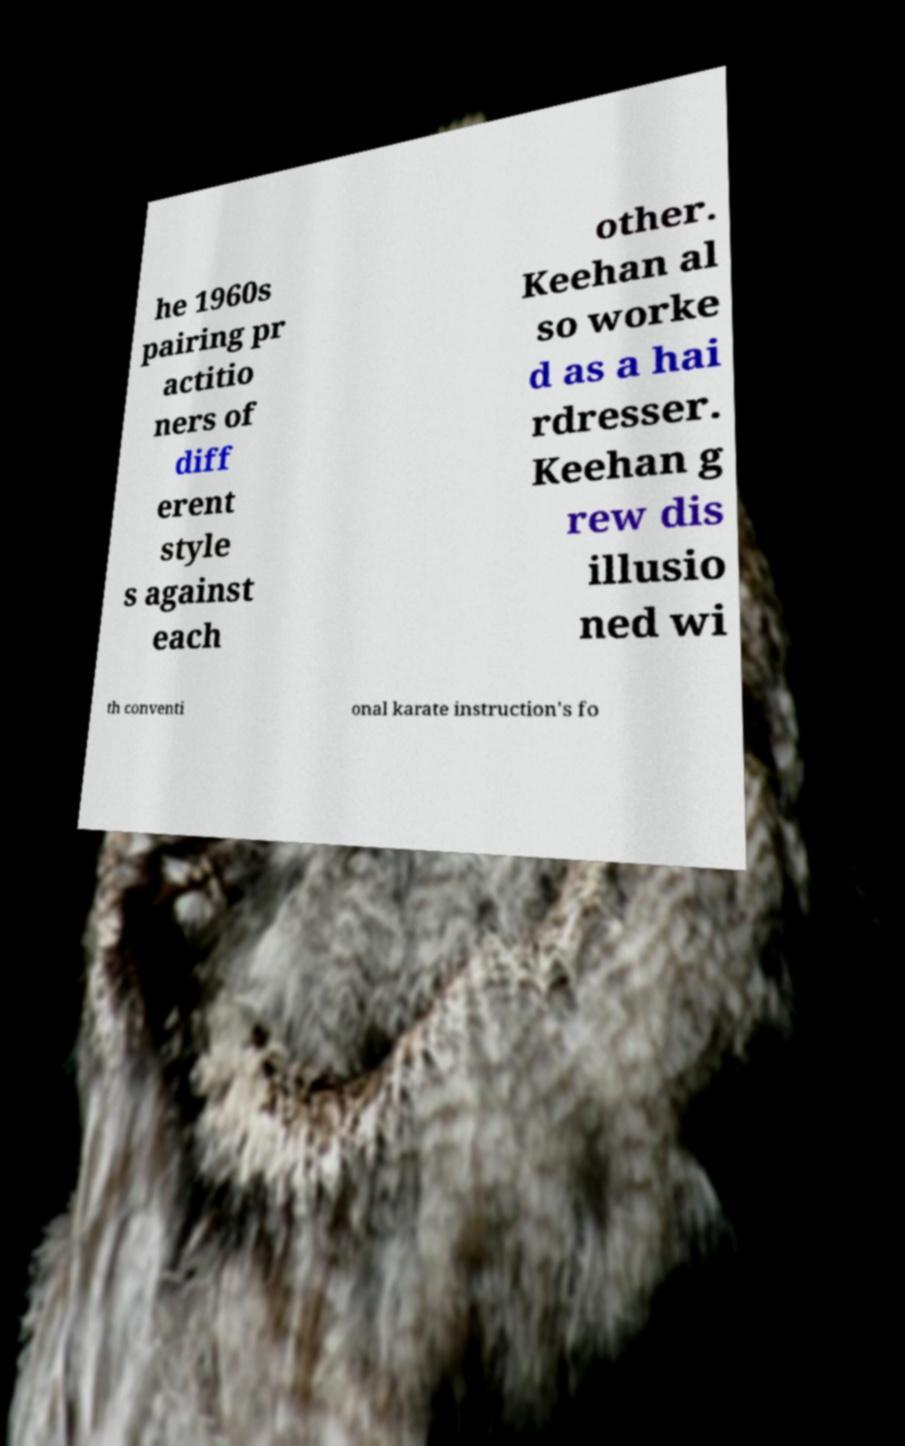Can you read and provide the text displayed in the image?This photo seems to have some interesting text. Can you extract and type it out for me? he 1960s pairing pr actitio ners of diff erent style s against each other. Keehan al so worke d as a hai rdresser. Keehan g rew dis illusio ned wi th conventi onal karate instruction's fo 